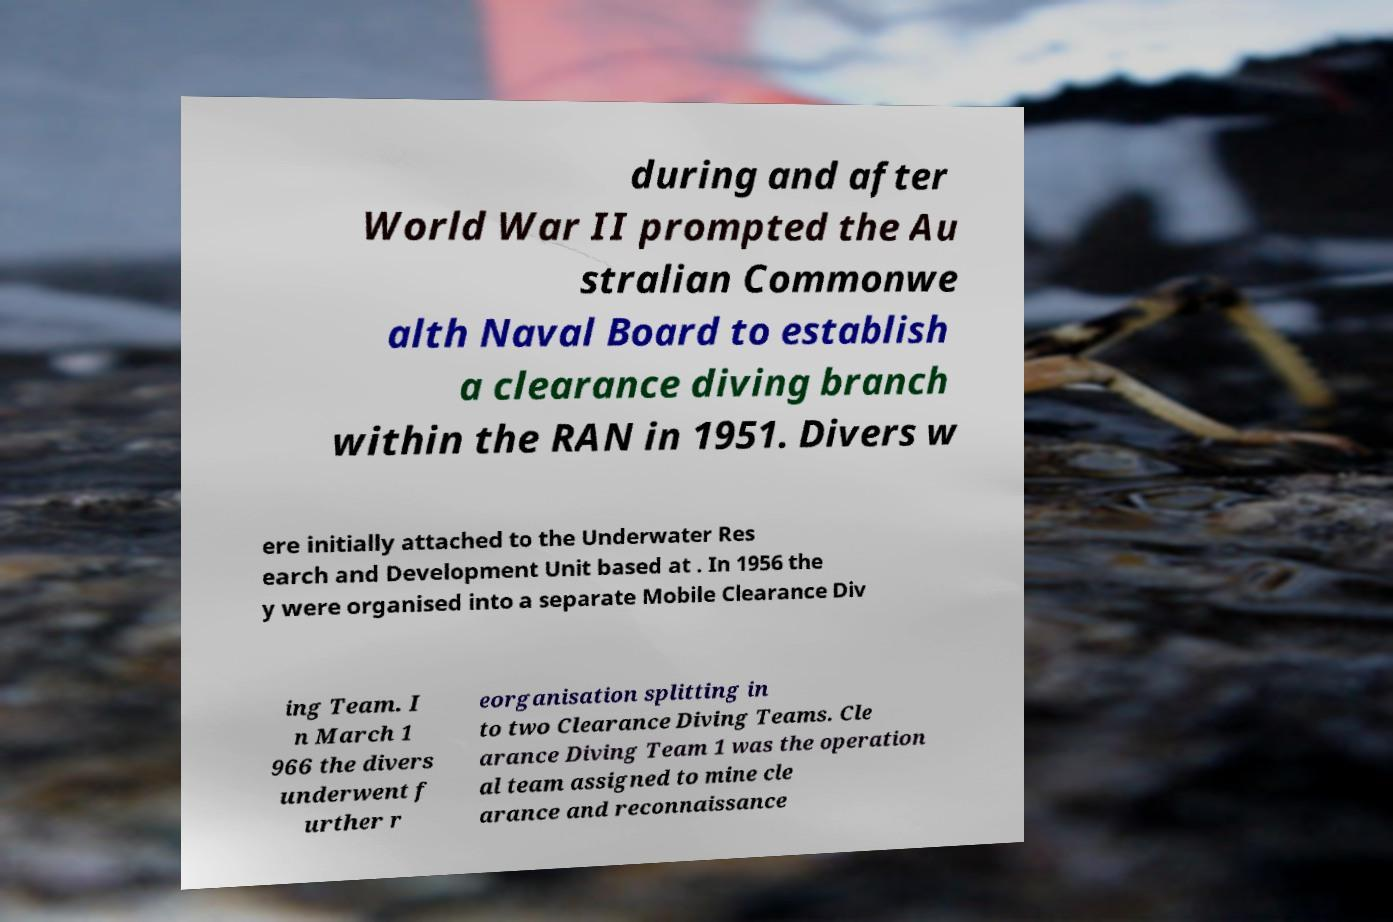Please identify and transcribe the text found in this image. during and after World War II prompted the Au stralian Commonwe alth Naval Board to establish a clearance diving branch within the RAN in 1951. Divers w ere initially attached to the Underwater Res earch and Development Unit based at . In 1956 the y were organised into a separate Mobile Clearance Div ing Team. I n March 1 966 the divers underwent f urther r eorganisation splitting in to two Clearance Diving Teams. Cle arance Diving Team 1 was the operation al team assigned to mine cle arance and reconnaissance 